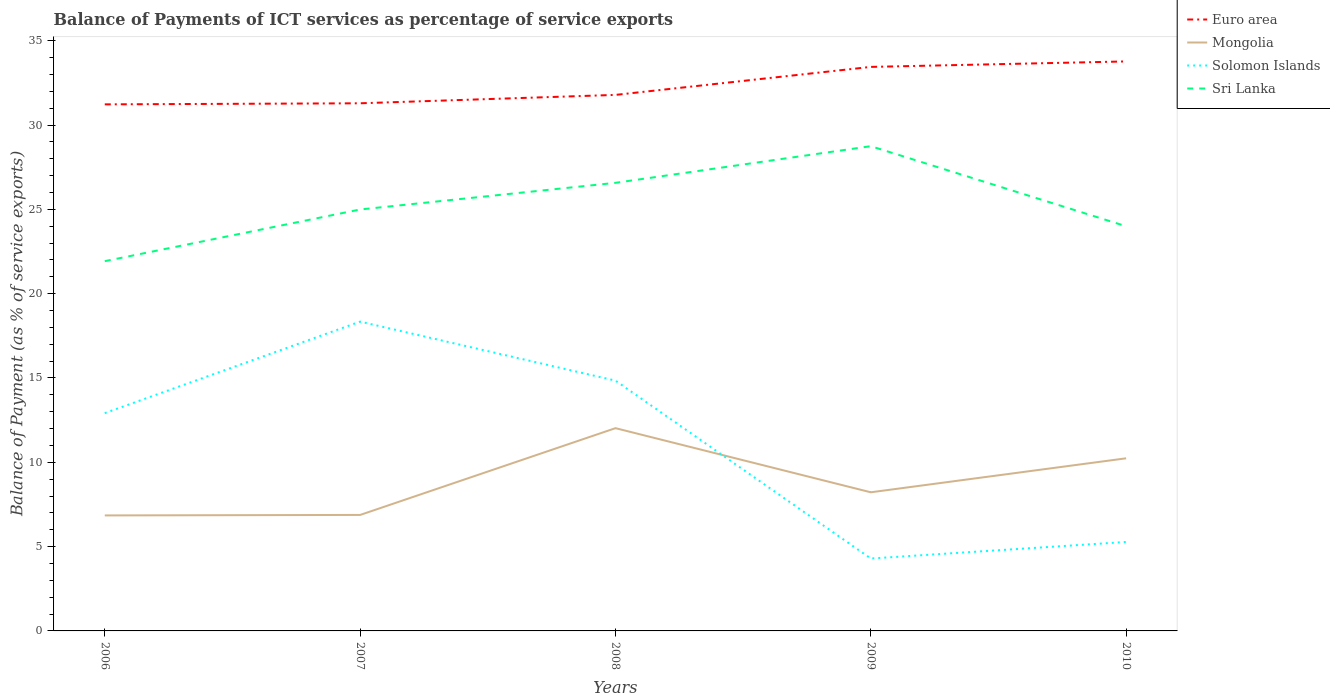How many different coloured lines are there?
Provide a succinct answer. 4. Is the number of lines equal to the number of legend labels?
Your answer should be compact. Yes. Across all years, what is the maximum balance of payments of ICT services in Mongolia?
Your answer should be very brief. 6.85. What is the total balance of payments of ICT services in Euro area in the graph?
Offer a terse response. -0.32. What is the difference between the highest and the second highest balance of payments of ICT services in Sri Lanka?
Keep it short and to the point. 6.82. What is the difference between the highest and the lowest balance of payments of ICT services in Solomon Islands?
Your answer should be compact. 3. How many years are there in the graph?
Your answer should be very brief. 5. What is the difference between two consecutive major ticks on the Y-axis?
Your answer should be compact. 5. Does the graph contain any zero values?
Your answer should be very brief. No. Where does the legend appear in the graph?
Your answer should be compact. Top right. How many legend labels are there?
Make the answer very short. 4. What is the title of the graph?
Offer a very short reply. Balance of Payments of ICT services as percentage of service exports. What is the label or title of the X-axis?
Ensure brevity in your answer.  Years. What is the label or title of the Y-axis?
Your answer should be very brief. Balance of Payment (as % of service exports). What is the Balance of Payment (as % of service exports) of Euro area in 2006?
Provide a succinct answer. 31.23. What is the Balance of Payment (as % of service exports) in Mongolia in 2006?
Provide a succinct answer. 6.85. What is the Balance of Payment (as % of service exports) in Solomon Islands in 2006?
Ensure brevity in your answer.  12.92. What is the Balance of Payment (as % of service exports) in Sri Lanka in 2006?
Make the answer very short. 21.93. What is the Balance of Payment (as % of service exports) in Euro area in 2007?
Keep it short and to the point. 31.29. What is the Balance of Payment (as % of service exports) of Mongolia in 2007?
Ensure brevity in your answer.  6.88. What is the Balance of Payment (as % of service exports) in Solomon Islands in 2007?
Give a very brief answer. 18.34. What is the Balance of Payment (as % of service exports) of Sri Lanka in 2007?
Offer a very short reply. 24.99. What is the Balance of Payment (as % of service exports) of Euro area in 2008?
Your response must be concise. 31.79. What is the Balance of Payment (as % of service exports) of Mongolia in 2008?
Your answer should be compact. 12.02. What is the Balance of Payment (as % of service exports) of Solomon Islands in 2008?
Ensure brevity in your answer.  14.84. What is the Balance of Payment (as % of service exports) in Sri Lanka in 2008?
Give a very brief answer. 26.57. What is the Balance of Payment (as % of service exports) of Euro area in 2009?
Provide a short and direct response. 33.45. What is the Balance of Payment (as % of service exports) in Mongolia in 2009?
Ensure brevity in your answer.  8.22. What is the Balance of Payment (as % of service exports) in Solomon Islands in 2009?
Ensure brevity in your answer.  4.29. What is the Balance of Payment (as % of service exports) in Sri Lanka in 2009?
Offer a very short reply. 28.75. What is the Balance of Payment (as % of service exports) in Euro area in 2010?
Offer a terse response. 33.77. What is the Balance of Payment (as % of service exports) in Mongolia in 2010?
Make the answer very short. 10.24. What is the Balance of Payment (as % of service exports) of Solomon Islands in 2010?
Give a very brief answer. 5.28. What is the Balance of Payment (as % of service exports) in Sri Lanka in 2010?
Keep it short and to the point. 24. Across all years, what is the maximum Balance of Payment (as % of service exports) in Euro area?
Offer a terse response. 33.77. Across all years, what is the maximum Balance of Payment (as % of service exports) of Mongolia?
Offer a very short reply. 12.02. Across all years, what is the maximum Balance of Payment (as % of service exports) of Solomon Islands?
Your response must be concise. 18.34. Across all years, what is the maximum Balance of Payment (as % of service exports) of Sri Lanka?
Your answer should be very brief. 28.75. Across all years, what is the minimum Balance of Payment (as % of service exports) in Euro area?
Offer a very short reply. 31.23. Across all years, what is the minimum Balance of Payment (as % of service exports) in Mongolia?
Your answer should be very brief. 6.85. Across all years, what is the minimum Balance of Payment (as % of service exports) of Solomon Islands?
Provide a succinct answer. 4.29. Across all years, what is the minimum Balance of Payment (as % of service exports) of Sri Lanka?
Ensure brevity in your answer.  21.93. What is the total Balance of Payment (as % of service exports) in Euro area in the graph?
Keep it short and to the point. 161.52. What is the total Balance of Payment (as % of service exports) in Mongolia in the graph?
Offer a terse response. 44.21. What is the total Balance of Payment (as % of service exports) of Solomon Islands in the graph?
Your answer should be compact. 55.67. What is the total Balance of Payment (as % of service exports) in Sri Lanka in the graph?
Ensure brevity in your answer.  126.24. What is the difference between the Balance of Payment (as % of service exports) of Euro area in 2006 and that in 2007?
Ensure brevity in your answer.  -0.06. What is the difference between the Balance of Payment (as % of service exports) in Mongolia in 2006 and that in 2007?
Keep it short and to the point. -0.03. What is the difference between the Balance of Payment (as % of service exports) of Solomon Islands in 2006 and that in 2007?
Your response must be concise. -5.43. What is the difference between the Balance of Payment (as % of service exports) in Sri Lanka in 2006 and that in 2007?
Provide a succinct answer. -3.06. What is the difference between the Balance of Payment (as % of service exports) in Euro area in 2006 and that in 2008?
Your answer should be very brief. -0.56. What is the difference between the Balance of Payment (as % of service exports) of Mongolia in 2006 and that in 2008?
Ensure brevity in your answer.  -5.17. What is the difference between the Balance of Payment (as % of service exports) in Solomon Islands in 2006 and that in 2008?
Your response must be concise. -1.93. What is the difference between the Balance of Payment (as % of service exports) in Sri Lanka in 2006 and that in 2008?
Make the answer very short. -4.65. What is the difference between the Balance of Payment (as % of service exports) of Euro area in 2006 and that in 2009?
Ensure brevity in your answer.  -2.22. What is the difference between the Balance of Payment (as % of service exports) in Mongolia in 2006 and that in 2009?
Offer a very short reply. -1.37. What is the difference between the Balance of Payment (as % of service exports) in Solomon Islands in 2006 and that in 2009?
Offer a very short reply. 8.62. What is the difference between the Balance of Payment (as % of service exports) in Sri Lanka in 2006 and that in 2009?
Offer a terse response. -6.82. What is the difference between the Balance of Payment (as % of service exports) in Euro area in 2006 and that in 2010?
Provide a short and direct response. -2.55. What is the difference between the Balance of Payment (as % of service exports) of Mongolia in 2006 and that in 2010?
Provide a short and direct response. -3.39. What is the difference between the Balance of Payment (as % of service exports) of Solomon Islands in 2006 and that in 2010?
Provide a short and direct response. 7.64. What is the difference between the Balance of Payment (as % of service exports) in Sri Lanka in 2006 and that in 2010?
Provide a short and direct response. -2.07. What is the difference between the Balance of Payment (as % of service exports) of Euro area in 2007 and that in 2008?
Your response must be concise. -0.5. What is the difference between the Balance of Payment (as % of service exports) of Mongolia in 2007 and that in 2008?
Provide a succinct answer. -5.15. What is the difference between the Balance of Payment (as % of service exports) in Solomon Islands in 2007 and that in 2008?
Provide a short and direct response. 3.5. What is the difference between the Balance of Payment (as % of service exports) of Sri Lanka in 2007 and that in 2008?
Offer a very short reply. -1.58. What is the difference between the Balance of Payment (as % of service exports) in Euro area in 2007 and that in 2009?
Offer a terse response. -2.16. What is the difference between the Balance of Payment (as % of service exports) in Mongolia in 2007 and that in 2009?
Make the answer very short. -1.34. What is the difference between the Balance of Payment (as % of service exports) in Solomon Islands in 2007 and that in 2009?
Your answer should be very brief. 14.05. What is the difference between the Balance of Payment (as % of service exports) of Sri Lanka in 2007 and that in 2009?
Offer a terse response. -3.75. What is the difference between the Balance of Payment (as % of service exports) of Euro area in 2007 and that in 2010?
Provide a succinct answer. -2.48. What is the difference between the Balance of Payment (as % of service exports) of Mongolia in 2007 and that in 2010?
Provide a succinct answer. -3.36. What is the difference between the Balance of Payment (as % of service exports) in Solomon Islands in 2007 and that in 2010?
Your answer should be very brief. 13.06. What is the difference between the Balance of Payment (as % of service exports) in Euro area in 2008 and that in 2009?
Make the answer very short. -1.66. What is the difference between the Balance of Payment (as % of service exports) of Mongolia in 2008 and that in 2009?
Your answer should be compact. 3.8. What is the difference between the Balance of Payment (as % of service exports) in Solomon Islands in 2008 and that in 2009?
Your answer should be compact. 10.55. What is the difference between the Balance of Payment (as % of service exports) of Sri Lanka in 2008 and that in 2009?
Provide a succinct answer. -2.17. What is the difference between the Balance of Payment (as % of service exports) in Euro area in 2008 and that in 2010?
Your response must be concise. -1.98. What is the difference between the Balance of Payment (as % of service exports) of Mongolia in 2008 and that in 2010?
Your answer should be compact. 1.79. What is the difference between the Balance of Payment (as % of service exports) in Solomon Islands in 2008 and that in 2010?
Keep it short and to the point. 9.57. What is the difference between the Balance of Payment (as % of service exports) of Sri Lanka in 2008 and that in 2010?
Provide a succinct answer. 2.58. What is the difference between the Balance of Payment (as % of service exports) of Euro area in 2009 and that in 2010?
Make the answer very short. -0.32. What is the difference between the Balance of Payment (as % of service exports) of Mongolia in 2009 and that in 2010?
Your response must be concise. -2.02. What is the difference between the Balance of Payment (as % of service exports) of Solomon Islands in 2009 and that in 2010?
Provide a succinct answer. -0.98. What is the difference between the Balance of Payment (as % of service exports) in Sri Lanka in 2009 and that in 2010?
Offer a terse response. 4.75. What is the difference between the Balance of Payment (as % of service exports) in Euro area in 2006 and the Balance of Payment (as % of service exports) in Mongolia in 2007?
Offer a terse response. 24.35. What is the difference between the Balance of Payment (as % of service exports) in Euro area in 2006 and the Balance of Payment (as % of service exports) in Solomon Islands in 2007?
Offer a very short reply. 12.88. What is the difference between the Balance of Payment (as % of service exports) of Euro area in 2006 and the Balance of Payment (as % of service exports) of Sri Lanka in 2007?
Your response must be concise. 6.23. What is the difference between the Balance of Payment (as % of service exports) in Mongolia in 2006 and the Balance of Payment (as % of service exports) in Solomon Islands in 2007?
Keep it short and to the point. -11.49. What is the difference between the Balance of Payment (as % of service exports) in Mongolia in 2006 and the Balance of Payment (as % of service exports) in Sri Lanka in 2007?
Make the answer very short. -18.14. What is the difference between the Balance of Payment (as % of service exports) of Solomon Islands in 2006 and the Balance of Payment (as % of service exports) of Sri Lanka in 2007?
Your answer should be very brief. -12.08. What is the difference between the Balance of Payment (as % of service exports) of Euro area in 2006 and the Balance of Payment (as % of service exports) of Mongolia in 2008?
Your response must be concise. 19.2. What is the difference between the Balance of Payment (as % of service exports) in Euro area in 2006 and the Balance of Payment (as % of service exports) in Solomon Islands in 2008?
Keep it short and to the point. 16.38. What is the difference between the Balance of Payment (as % of service exports) in Euro area in 2006 and the Balance of Payment (as % of service exports) in Sri Lanka in 2008?
Give a very brief answer. 4.65. What is the difference between the Balance of Payment (as % of service exports) of Mongolia in 2006 and the Balance of Payment (as % of service exports) of Solomon Islands in 2008?
Offer a very short reply. -7.99. What is the difference between the Balance of Payment (as % of service exports) of Mongolia in 2006 and the Balance of Payment (as % of service exports) of Sri Lanka in 2008?
Offer a terse response. -19.72. What is the difference between the Balance of Payment (as % of service exports) in Solomon Islands in 2006 and the Balance of Payment (as % of service exports) in Sri Lanka in 2008?
Your response must be concise. -13.66. What is the difference between the Balance of Payment (as % of service exports) in Euro area in 2006 and the Balance of Payment (as % of service exports) in Mongolia in 2009?
Your answer should be very brief. 23. What is the difference between the Balance of Payment (as % of service exports) in Euro area in 2006 and the Balance of Payment (as % of service exports) in Solomon Islands in 2009?
Your answer should be very brief. 26.93. What is the difference between the Balance of Payment (as % of service exports) of Euro area in 2006 and the Balance of Payment (as % of service exports) of Sri Lanka in 2009?
Ensure brevity in your answer.  2.48. What is the difference between the Balance of Payment (as % of service exports) of Mongolia in 2006 and the Balance of Payment (as % of service exports) of Solomon Islands in 2009?
Make the answer very short. 2.56. What is the difference between the Balance of Payment (as % of service exports) in Mongolia in 2006 and the Balance of Payment (as % of service exports) in Sri Lanka in 2009?
Provide a short and direct response. -21.9. What is the difference between the Balance of Payment (as % of service exports) of Solomon Islands in 2006 and the Balance of Payment (as % of service exports) of Sri Lanka in 2009?
Provide a short and direct response. -15.83. What is the difference between the Balance of Payment (as % of service exports) in Euro area in 2006 and the Balance of Payment (as % of service exports) in Mongolia in 2010?
Provide a short and direct response. 20.99. What is the difference between the Balance of Payment (as % of service exports) of Euro area in 2006 and the Balance of Payment (as % of service exports) of Solomon Islands in 2010?
Your response must be concise. 25.95. What is the difference between the Balance of Payment (as % of service exports) in Euro area in 2006 and the Balance of Payment (as % of service exports) in Sri Lanka in 2010?
Keep it short and to the point. 7.23. What is the difference between the Balance of Payment (as % of service exports) in Mongolia in 2006 and the Balance of Payment (as % of service exports) in Solomon Islands in 2010?
Provide a short and direct response. 1.57. What is the difference between the Balance of Payment (as % of service exports) in Mongolia in 2006 and the Balance of Payment (as % of service exports) in Sri Lanka in 2010?
Your answer should be compact. -17.15. What is the difference between the Balance of Payment (as % of service exports) in Solomon Islands in 2006 and the Balance of Payment (as % of service exports) in Sri Lanka in 2010?
Offer a very short reply. -11.08. What is the difference between the Balance of Payment (as % of service exports) of Euro area in 2007 and the Balance of Payment (as % of service exports) of Mongolia in 2008?
Your answer should be very brief. 19.27. What is the difference between the Balance of Payment (as % of service exports) in Euro area in 2007 and the Balance of Payment (as % of service exports) in Solomon Islands in 2008?
Your answer should be compact. 16.45. What is the difference between the Balance of Payment (as % of service exports) of Euro area in 2007 and the Balance of Payment (as % of service exports) of Sri Lanka in 2008?
Offer a very short reply. 4.72. What is the difference between the Balance of Payment (as % of service exports) in Mongolia in 2007 and the Balance of Payment (as % of service exports) in Solomon Islands in 2008?
Your answer should be very brief. -7.97. What is the difference between the Balance of Payment (as % of service exports) of Mongolia in 2007 and the Balance of Payment (as % of service exports) of Sri Lanka in 2008?
Offer a terse response. -19.7. What is the difference between the Balance of Payment (as % of service exports) in Solomon Islands in 2007 and the Balance of Payment (as % of service exports) in Sri Lanka in 2008?
Offer a very short reply. -8.23. What is the difference between the Balance of Payment (as % of service exports) of Euro area in 2007 and the Balance of Payment (as % of service exports) of Mongolia in 2009?
Provide a short and direct response. 23.07. What is the difference between the Balance of Payment (as % of service exports) of Euro area in 2007 and the Balance of Payment (as % of service exports) of Solomon Islands in 2009?
Provide a succinct answer. 27. What is the difference between the Balance of Payment (as % of service exports) of Euro area in 2007 and the Balance of Payment (as % of service exports) of Sri Lanka in 2009?
Offer a terse response. 2.54. What is the difference between the Balance of Payment (as % of service exports) in Mongolia in 2007 and the Balance of Payment (as % of service exports) in Solomon Islands in 2009?
Keep it short and to the point. 2.58. What is the difference between the Balance of Payment (as % of service exports) of Mongolia in 2007 and the Balance of Payment (as % of service exports) of Sri Lanka in 2009?
Offer a very short reply. -21.87. What is the difference between the Balance of Payment (as % of service exports) of Solomon Islands in 2007 and the Balance of Payment (as % of service exports) of Sri Lanka in 2009?
Provide a short and direct response. -10.41. What is the difference between the Balance of Payment (as % of service exports) of Euro area in 2007 and the Balance of Payment (as % of service exports) of Mongolia in 2010?
Offer a very short reply. 21.05. What is the difference between the Balance of Payment (as % of service exports) of Euro area in 2007 and the Balance of Payment (as % of service exports) of Solomon Islands in 2010?
Keep it short and to the point. 26.01. What is the difference between the Balance of Payment (as % of service exports) in Euro area in 2007 and the Balance of Payment (as % of service exports) in Sri Lanka in 2010?
Provide a short and direct response. 7.29. What is the difference between the Balance of Payment (as % of service exports) of Mongolia in 2007 and the Balance of Payment (as % of service exports) of Solomon Islands in 2010?
Ensure brevity in your answer.  1.6. What is the difference between the Balance of Payment (as % of service exports) of Mongolia in 2007 and the Balance of Payment (as % of service exports) of Sri Lanka in 2010?
Your response must be concise. -17.12. What is the difference between the Balance of Payment (as % of service exports) in Solomon Islands in 2007 and the Balance of Payment (as % of service exports) in Sri Lanka in 2010?
Keep it short and to the point. -5.66. What is the difference between the Balance of Payment (as % of service exports) in Euro area in 2008 and the Balance of Payment (as % of service exports) in Mongolia in 2009?
Ensure brevity in your answer.  23.57. What is the difference between the Balance of Payment (as % of service exports) of Euro area in 2008 and the Balance of Payment (as % of service exports) of Solomon Islands in 2009?
Offer a terse response. 27.49. What is the difference between the Balance of Payment (as % of service exports) of Euro area in 2008 and the Balance of Payment (as % of service exports) of Sri Lanka in 2009?
Ensure brevity in your answer.  3.04. What is the difference between the Balance of Payment (as % of service exports) in Mongolia in 2008 and the Balance of Payment (as % of service exports) in Solomon Islands in 2009?
Your answer should be compact. 7.73. What is the difference between the Balance of Payment (as % of service exports) of Mongolia in 2008 and the Balance of Payment (as % of service exports) of Sri Lanka in 2009?
Make the answer very short. -16.72. What is the difference between the Balance of Payment (as % of service exports) of Solomon Islands in 2008 and the Balance of Payment (as % of service exports) of Sri Lanka in 2009?
Offer a terse response. -13.9. What is the difference between the Balance of Payment (as % of service exports) in Euro area in 2008 and the Balance of Payment (as % of service exports) in Mongolia in 2010?
Offer a very short reply. 21.55. What is the difference between the Balance of Payment (as % of service exports) in Euro area in 2008 and the Balance of Payment (as % of service exports) in Solomon Islands in 2010?
Give a very brief answer. 26.51. What is the difference between the Balance of Payment (as % of service exports) of Euro area in 2008 and the Balance of Payment (as % of service exports) of Sri Lanka in 2010?
Make the answer very short. 7.79. What is the difference between the Balance of Payment (as % of service exports) of Mongolia in 2008 and the Balance of Payment (as % of service exports) of Solomon Islands in 2010?
Offer a very short reply. 6.75. What is the difference between the Balance of Payment (as % of service exports) in Mongolia in 2008 and the Balance of Payment (as % of service exports) in Sri Lanka in 2010?
Offer a very short reply. -11.97. What is the difference between the Balance of Payment (as % of service exports) in Solomon Islands in 2008 and the Balance of Payment (as % of service exports) in Sri Lanka in 2010?
Your answer should be compact. -9.15. What is the difference between the Balance of Payment (as % of service exports) of Euro area in 2009 and the Balance of Payment (as % of service exports) of Mongolia in 2010?
Your response must be concise. 23.21. What is the difference between the Balance of Payment (as % of service exports) of Euro area in 2009 and the Balance of Payment (as % of service exports) of Solomon Islands in 2010?
Offer a very short reply. 28.17. What is the difference between the Balance of Payment (as % of service exports) of Euro area in 2009 and the Balance of Payment (as % of service exports) of Sri Lanka in 2010?
Make the answer very short. 9.45. What is the difference between the Balance of Payment (as % of service exports) of Mongolia in 2009 and the Balance of Payment (as % of service exports) of Solomon Islands in 2010?
Make the answer very short. 2.94. What is the difference between the Balance of Payment (as % of service exports) in Mongolia in 2009 and the Balance of Payment (as % of service exports) in Sri Lanka in 2010?
Offer a very short reply. -15.78. What is the difference between the Balance of Payment (as % of service exports) of Solomon Islands in 2009 and the Balance of Payment (as % of service exports) of Sri Lanka in 2010?
Provide a succinct answer. -19.7. What is the average Balance of Payment (as % of service exports) in Euro area per year?
Provide a short and direct response. 32.3. What is the average Balance of Payment (as % of service exports) of Mongolia per year?
Make the answer very short. 8.84. What is the average Balance of Payment (as % of service exports) in Solomon Islands per year?
Offer a very short reply. 11.13. What is the average Balance of Payment (as % of service exports) of Sri Lanka per year?
Your response must be concise. 25.25. In the year 2006, what is the difference between the Balance of Payment (as % of service exports) in Euro area and Balance of Payment (as % of service exports) in Mongolia?
Provide a short and direct response. 24.38. In the year 2006, what is the difference between the Balance of Payment (as % of service exports) in Euro area and Balance of Payment (as % of service exports) in Solomon Islands?
Your response must be concise. 18.31. In the year 2006, what is the difference between the Balance of Payment (as % of service exports) of Euro area and Balance of Payment (as % of service exports) of Sri Lanka?
Make the answer very short. 9.3. In the year 2006, what is the difference between the Balance of Payment (as % of service exports) of Mongolia and Balance of Payment (as % of service exports) of Solomon Islands?
Ensure brevity in your answer.  -6.07. In the year 2006, what is the difference between the Balance of Payment (as % of service exports) of Mongolia and Balance of Payment (as % of service exports) of Sri Lanka?
Ensure brevity in your answer.  -15.08. In the year 2006, what is the difference between the Balance of Payment (as % of service exports) in Solomon Islands and Balance of Payment (as % of service exports) in Sri Lanka?
Offer a terse response. -9.01. In the year 2007, what is the difference between the Balance of Payment (as % of service exports) in Euro area and Balance of Payment (as % of service exports) in Mongolia?
Provide a succinct answer. 24.41. In the year 2007, what is the difference between the Balance of Payment (as % of service exports) of Euro area and Balance of Payment (as % of service exports) of Solomon Islands?
Give a very brief answer. 12.95. In the year 2007, what is the difference between the Balance of Payment (as % of service exports) of Euro area and Balance of Payment (as % of service exports) of Sri Lanka?
Offer a terse response. 6.3. In the year 2007, what is the difference between the Balance of Payment (as % of service exports) of Mongolia and Balance of Payment (as % of service exports) of Solomon Islands?
Provide a succinct answer. -11.46. In the year 2007, what is the difference between the Balance of Payment (as % of service exports) in Mongolia and Balance of Payment (as % of service exports) in Sri Lanka?
Provide a succinct answer. -18.11. In the year 2007, what is the difference between the Balance of Payment (as % of service exports) in Solomon Islands and Balance of Payment (as % of service exports) in Sri Lanka?
Give a very brief answer. -6.65. In the year 2008, what is the difference between the Balance of Payment (as % of service exports) of Euro area and Balance of Payment (as % of service exports) of Mongolia?
Give a very brief answer. 19.76. In the year 2008, what is the difference between the Balance of Payment (as % of service exports) in Euro area and Balance of Payment (as % of service exports) in Solomon Islands?
Give a very brief answer. 16.94. In the year 2008, what is the difference between the Balance of Payment (as % of service exports) in Euro area and Balance of Payment (as % of service exports) in Sri Lanka?
Your response must be concise. 5.21. In the year 2008, what is the difference between the Balance of Payment (as % of service exports) in Mongolia and Balance of Payment (as % of service exports) in Solomon Islands?
Ensure brevity in your answer.  -2.82. In the year 2008, what is the difference between the Balance of Payment (as % of service exports) in Mongolia and Balance of Payment (as % of service exports) in Sri Lanka?
Make the answer very short. -14.55. In the year 2008, what is the difference between the Balance of Payment (as % of service exports) of Solomon Islands and Balance of Payment (as % of service exports) of Sri Lanka?
Give a very brief answer. -11.73. In the year 2009, what is the difference between the Balance of Payment (as % of service exports) of Euro area and Balance of Payment (as % of service exports) of Mongolia?
Your answer should be very brief. 25.23. In the year 2009, what is the difference between the Balance of Payment (as % of service exports) of Euro area and Balance of Payment (as % of service exports) of Solomon Islands?
Keep it short and to the point. 29.15. In the year 2009, what is the difference between the Balance of Payment (as % of service exports) of Euro area and Balance of Payment (as % of service exports) of Sri Lanka?
Your answer should be very brief. 4.7. In the year 2009, what is the difference between the Balance of Payment (as % of service exports) in Mongolia and Balance of Payment (as % of service exports) in Solomon Islands?
Provide a short and direct response. 3.93. In the year 2009, what is the difference between the Balance of Payment (as % of service exports) of Mongolia and Balance of Payment (as % of service exports) of Sri Lanka?
Provide a short and direct response. -20.53. In the year 2009, what is the difference between the Balance of Payment (as % of service exports) in Solomon Islands and Balance of Payment (as % of service exports) in Sri Lanka?
Your answer should be very brief. -24.45. In the year 2010, what is the difference between the Balance of Payment (as % of service exports) of Euro area and Balance of Payment (as % of service exports) of Mongolia?
Your answer should be very brief. 23.54. In the year 2010, what is the difference between the Balance of Payment (as % of service exports) of Euro area and Balance of Payment (as % of service exports) of Solomon Islands?
Your response must be concise. 28.5. In the year 2010, what is the difference between the Balance of Payment (as % of service exports) of Euro area and Balance of Payment (as % of service exports) of Sri Lanka?
Offer a terse response. 9.77. In the year 2010, what is the difference between the Balance of Payment (as % of service exports) in Mongolia and Balance of Payment (as % of service exports) in Solomon Islands?
Provide a short and direct response. 4.96. In the year 2010, what is the difference between the Balance of Payment (as % of service exports) in Mongolia and Balance of Payment (as % of service exports) in Sri Lanka?
Ensure brevity in your answer.  -13.76. In the year 2010, what is the difference between the Balance of Payment (as % of service exports) of Solomon Islands and Balance of Payment (as % of service exports) of Sri Lanka?
Your answer should be very brief. -18.72. What is the ratio of the Balance of Payment (as % of service exports) in Solomon Islands in 2006 to that in 2007?
Give a very brief answer. 0.7. What is the ratio of the Balance of Payment (as % of service exports) of Sri Lanka in 2006 to that in 2007?
Give a very brief answer. 0.88. What is the ratio of the Balance of Payment (as % of service exports) of Euro area in 2006 to that in 2008?
Keep it short and to the point. 0.98. What is the ratio of the Balance of Payment (as % of service exports) of Mongolia in 2006 to that in 2008?
Offer a very short reply. 0.57. What is the ratio of the Balance of Payment (as % of service exports) in Solomon Islands in 2006 to that in 2008?
Ensure brevity in your answer.  0.87. What is the ratio of the Balance of Payment (as % of service exports) of Sri Lanka in 2006 to that in 2008?
Provide a short and direct response. 0.83. What is the ratio of the Balance of Payment (as % of service exports) of Euro area in 2006 to that in 2009?
Your answer should be very brief. 0.93. What is the ratio of the Balance of Payment (as % of service exports) in Mongolia in 2006 to that in 2009?
Provide a short and direct response. 0.83. What is the ratio of the Balance of Payment (as % of service exports) of Solomon Islands in 2006 to that in 2009?
Provide a short and direct response. 3.01. What is the ratio of the Balance of Payment (as % of service exports) in Sri Lanka in 2006 to that in 2009?
Your response must be concise. 0.76. What is the ratio of the Balance of Payment (as % of service exports) of Euro area in 2006 to that in 2010?
Keep it short and to the point. 0.92. What is the ratio of the Balance of Payment (as % of service exports) in Mongolia in 2006 to that in 2010?
Give a very brief answer. 0.67. What is the ratio of the Balance of Payment (as % of service exports) of Solomon Islands in 2006 to that in 2010?
Provide a succinct answer. 2.45. What is the ratio of the Balance of Payment (as % of service exports) of Sri Lanka in 2006 to that in 2010?
Your response must be concise. 0.91. What is the ratio of the Balance of Payment (as % of service exports) in Euro area in 2007 to that in 2008?
Offer a very short reply. 0.98. What is the ratio of the Balance of Payment (as % of service exports) of Mongolia in 2007 to that in 2008?
Offer a very short reply. 0.57. What is the ratio of the Balance of Payment (as % of service exports) of Solomon Islands in 2007 to that in 2008?
Provide a short and direct response. 1.24. What is the ratio of the Balance of Payment (as % of service exports) of Sri Lanka in 2007 to that in 2008?
Make the answer very short. 0.94. What is the ratio of the Balance of Payment (as % of service exports) in Euro area in 2007 to that in 2009?
Your response must be concise. 0.94. What is the ratio of the Balance of Payment (as % of service exports) of Mongolia in 2007 to that in 2009?
Offer a terse response. 0.84. What is the ratio of the Balance of Payment (as % of service exports) of Solomon Islands in 2007 to that in 2009?
Give a very brief answer. 4.27. What is the ratio of the Balance of Payment (as % of service exports) in Sri Lanka in 2007 to that in 2009?
Keep it short and to the point. 0.87. What is the ratio of the Balance of Payment (as % of service exports) of Euro area in 2007 to that in 2010?
Offer a very short reply. 0.93. What is the ratio of the Balance of Payment (as % of service exports) in Mongolia in 2007 to that in 2010?
Your answer should be very brief. 0.67. What is the ratio of the Balance of Payment (as % of service exports) of Solomon Islands in 2007 to that in 2010?
Your answer should be very brief. 3.48. What is the ratio of the Balance of Payment (as % of service exports) in Sri Lanka in 2007 to that in 2010?
Ensure brevity in your answer.  1.04. What is the ratio of the Balance of Payment (as % of service exports) of Euro area in 2008 to that in 2009?
Offer a very short reply. 0.95. What is the ratio of the Balance of Payment (as % of service exports) in Mongolia in 2008 to that in 2009?
Offer a very short reply. 1.46. What is the ratio of the Balance of Payment (as % of service exports) of Solomon Islands in 2008 to that in 2009?
Your response must be concise. 3.46. What is the ratio of the Balance of Payment (as % of service exports) in Sri Lanka in 2008 to that in 2009?
Provide a short and direct response. 0.92. What is the ratio of the Balance of Payment (as % of service exports) of Mongolia in 2008 to that in 2010?
Provide a succinct answer. 1.17. What is the ratio of the Balance of Payment (as % of service exports) in Solomon Islands in 2008 to that in 2010?
Provide a short and direct response. 2.81. What is the ratio of the Balance of Payment (as % of service exports) in Sri Lanka in 2008 to that in 2010?
Make the answer very short. 1.11. What is the ratio of the Balance of Payment (as % of service exports) of Mongolia in 2009 to that in 2010?
Ensure brevity in your answer.  0.8. What is the ratio of the Balance of Payment (as % of service exports) in Solomon Islands in 2009 to that in 2010?
Provide a short and direct response. 0.81. What is the ratio of the Balance of Payment (as % of service exports) in Sri Lanka in 2009 to that in 2010?
Ensure brevity in your answer.  1.2. What is the difference between the highest and the second highest Balance of Payment (as % of service exports) in Euro area?
Provide a short and direct response. 0.32. What is the difference between the highest and the second highest Balance of Payment (as % of service exports) of Mongolia?
Make the answer very short. 1.79. What is the difference between the highest and the second highest Balance of Payment (as % of service exports) of Solomon Islands?
Offer a terse response. 3.5. What is the difference between the highest and the second highest Balance of Payment (as % of service exports) of Sri Lanka?
Your answer should be compact. 2.17. What is the difference between the highest and the lowest Balance of Payment (as % of service exports) in Euro area?
Ensure brevity in your answer.  2.55. What is the difference between the highest and the lowest Balance of Payment (as % of service exports) of Mongolia?
Provide a succinct answer. 5.17. What is the difference between the highest and the lowest Balance of Payment (as % of service exports) in Solomon Islands?
Make the answer very short. 14.05. What is the difference between the highest and the lowest Balance of Payment (as % of service exports) of Sri Lanka?
Your answer should be compact. 6.82. 